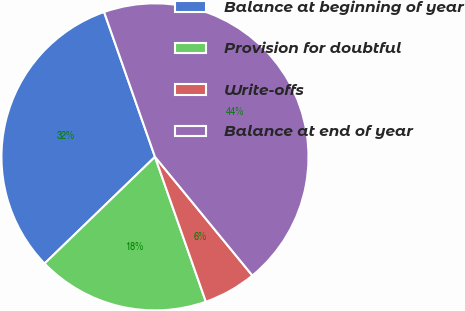Convert chart to OTSL. <chart><loc_0><loc_0><loc_500><loc_500><pie_chart><fcel>Balance at beginning of year<fcel>Provision for doubtful<fcel>Write-offs<fcel>Balance at end of year<nl><fcel>31.85%<fcel>18.15%<fcel>5.56%<fcel>44.44%<nl></chart> 